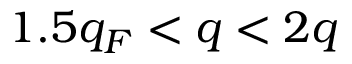<formula> <loc_0><loc_0><loc_500><loc_500>1 . 5 q _ { F } < q < 2 q</formula> 